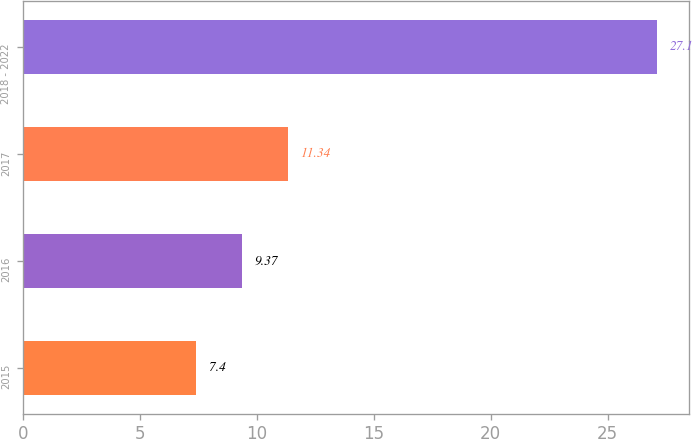Convert chart. <chart><loc_0><loc_0><loc_500><loc_500><bar_chart><fcel>2015<fcel>2016<fcel>2017<fcel>2018 - 2022<nl><fcel>7.4<fcel>9.37<fcel>11.34<fcel>27.1<nl></chart> 